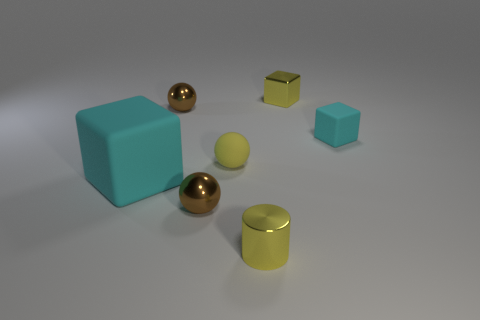What number of small objects are cyan cubes or brown metal objects?
Ensure brevity in your answer.  3. What is the shape of the brown object that is behind the large cyan matte thing?
Offer a very short reply. Sphere. Is there a matte cube that has the same color as the shiny cylinder?
Make the answer very short. No. There is a yellow rubber thing that is behind the large matte cube; is its size the same as the ball that is in front of the yellow rubber thing?
Offer a very short reply. Yes. Are there more small brown shiny balls to the right of the small yellow cube than big matte blocks that are behind the tiny rubber ball?
Provide a succinct answer. No. Are there any big brown cubes made of the same material as the big thing?
Offer a very short reply. No. Is the big block the same color as the matte sphere?
Offer a terse response. No. What is the material of the small yellow object that is both behind the tiny yellow metal cylinder and in front of the small rubber block?
Make the answer very short. Rubber. The big matte block is what color?
Give a very brief answer. Cyan. How many other yellow things are the same shape as the big thing?
Your answer should be very brief. 1. 